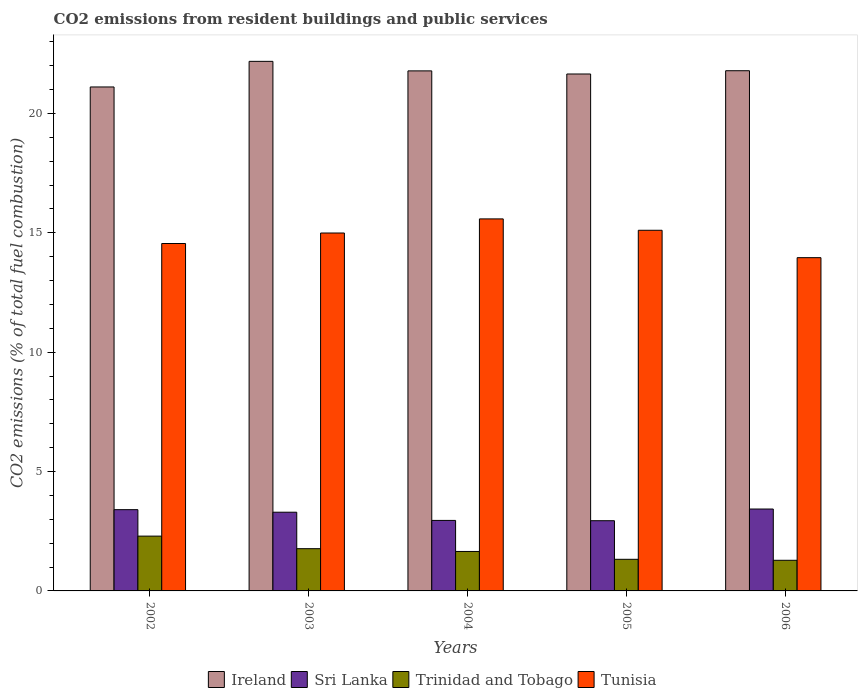How many groups of bars are there?
Ensure brevity in your answer.  5. Are the number of bars per tick equal to the number of legend labels?
Your response must be concise. Yes. Are the number of bars on each tick of the X-axis equal?
Keep it short and to the point. Yes. How many bars are there on the 1st tick from the right?
Your answer should be compact. 4. What is the total CO2 emitted in Trinidad and Tobago in 2002?
Your answer should be very brief. 2.3. Across all years, what is the maximum total CO2 emitted in Trinidad and Tobago?
Provide a short and direct response. 2.3. Across all years, what is the minimum total CO2 emitted in Sri Lanka?
Your answer should be compact. 2.94. In which year was the total CO2 emitted in Ireland minimum?
Your response must be concise. 2002. What is the total total CO2 emitted in Sri Lanka in the graph?
Provide a succinct answer. 16.03. What is the difference between the total CO2 emitted in Trinidad and Tobago in 2003 and that in 2005?
Your answer should be compact. 0.45. What is the difference between the total CO2 emitted in Trinidad and Tobago in 2005 and the total CO2 emitted in Ireland in 2004?
Give a very brief answer. -20.46. What is the average total CO2 emitted in Trinidad and Tobago per year?
Offer a very short reply. 1.67. In the year 2003, what is the difference between the total CO2 emitted in Ireland and total CO2 emitted in Trinidad and Tobago?
Ensure brevity in your answer.  20.41. In how many years, is the total CO2 emitted in Sri Lanka greater than 3?
Offer a terse response. 3. What is the ratio of the total CO2 emitted in Tunisia in 2003 to that in 2005?
Ensure brevity in your answer.  0.99. Is the total CO2 emitted in Trinidad and Tobago in 2002 less than that in 2006?
Ensure brevity in your answer.  No. What is the difference between the highest and the second highest total CO2 emitted in Sri Lanka?
Your answer should be compact. 0.03. What is the difference between the highest and the lowest total CO2 emitted in Sri Lanka?
Offer a very short reply. 0.49. In how many years, is the total CO2 emitted in Trinidad and Tobago greater than the average total CO2 emitted in Trinidad and Tobago taken over all years?
Make the answer very short. 2. Is it the case that in every year, the sum of the total CO2 emitted in Sri Lanka and total CO2 emitted in Ireland is greater than the sum of total CO2 emitted in Trinidad and Tobago and total CO2 emitted in Tunisia?
Your answer should be very brief. Yes. What does the 2nd bar from the left in 2002 represents?
Offer a terse response. Sri Lanka. What does the 3rd bar from the right in 2006 represents?
Your answer should be very brief. Sri Lanka. How many bars are there?
Your response must be concise. 20. How many legend labels are there?
Your answer should be very brief. 4. What is the title of the graph?
Ensure brevity in your answer.  CO2 emissions from resident buildings and public services. Does "Bolivia" appear as one of the legend labels in the graph?
Offer a terse response. No. What is the label or title of the X-axis?
Provide a short and direct response. Years. What is the label or title of the Y-axis?
Your answer should be very brief. CO2 emissions (% of total fuel combustion). What is the CO2 emissions (% of total fuel combustion) of Ireland in 2002?
Give a very brief answer. 21.11. What is the CO2 emissions (% of total fuel combustion) of Sri Lanka in 2002?
Ensure brevity in your answer.  3.4. What is the CO2 emissions (% of total fuel combustion) of Trinidad and Tobago in 2002?
Give a very brief answer. 2.3. What is the CO2 emissions (% of total fuel combustion) of Tunisia in 2002?
Keep it short and to the point. 14.55. What is the CO2 emissions (% of total fuel combustion) in Ireland in 2003?
Offer a terse response. 22.18. What is the CO2 emissions (% of total fuel combustion) of Sri Lanka in 2003?
Offer a very short reply. 3.3. What is the CO2 emissions (% of total fuel combustion) of Trinidad and Tobago in 2003?
Provide a short and direct response. 1.77. What is the CO2 emissions (% of total fuel combustion) in Tunisia in 2003?
Your response must be concise. 14.99. What is the CO2 emissions (% of total fuel combustion) of Ireland in 2004?
Make the answer very short. 21.78. What is the CO2 emissions (% of total fuel combustion) in Sri Lanka in 2004?
Your answer should be compact. 2.95. What is the CO2 emissions (% of total fuel combustion) of Trinidad and Tobago in 2004?
Keep it short and to the point. 1.65. What is the CO2 emissions (% of total fuel combustion) of Tunisia in 2004?
Your answer should be very brief. 15.58. What is the CO2 emissions (% of total fuel combustion) in Ireland in 2005?
Your response must be concise. 21.65. What is the CO2 emissions (% of total fuel combustion) of Sri Lanka in 2005?
Your answer should be very brief. 2.94. What is the CO2 emissions (% of total fuel combustion) of Trinidad and Tobago in 2005?
Ensure brevity in your answer.  1.32. What is the CO2 emissions (% of total fuel combustion) in Tunisia in 2005?
Provide a short and direct response. 15.11. What is the CO2 emissions (% of total fuel combustion) of Ireland in 2006?
Offer a terse response. 21.79. What is the CO2 emissions (% of total fuel combustion) of Sri Lanka in 2006?
Your answer should be compact. 3.43. What is the CO2 emissions (% of total fuel combustion) of Trinidad and Tobago in 2006?
Ensure brevity in your answer.  1.28. What is the CO2 emissions (% of total fuel combustion) of Tunisia in 2006?
Provide a short and direct response. 13.96. Across all years, what is the maximum CO2 emissions (% of total fuel combustion) in Ireland?
Provide a short and direct response. 22.18. Across all years, what is the maximum CO2 emissions (% of total fuel combustion) of Sri Lanka?
Your answer should be very brief. 3.43. Across all years, what is the maximum CO2 emissions (% of total fuel combustion) in Trinidad and Tobago?
Provide a succinct answer. 2.3. Across all years, what is the maximum CO2 emissions (% of total fuel combustion) of Tunisia?
Your answer should be very brief. 15.58. Across all years, what is the minimum CO2 emissions (% of total fuel combustion) in Ireland?
Offer a very short reply. 21.11. Across all years, what is the minimum CO2 emissions (% of total fuel combustion) in Sri Lanka?
Offer a very short reply. 2.94. Across all years, what is the minimum CO2 emissions (% of total fuel combustion) in Trinidad and Tobago?
Make the answer very short. 1.28. Across all years, what is the minimum CO2 emissions (% of total fuel combustion) of Tunisia?
Make the answer very short. 13.96. What is the total CO2 emissions (% of total fuel combustion) of Ireland in the graph?
Keep it short and to the point. 108.52. What is the total CO2 emissions (% of total fuel combustion) in Sri Lanka in the graph?
Keep it short and to the point. 16.03. What is the total CO2 emissions (% of total fuel combustion) of Trinidad and Tobago in the graph?
Your answer should be compact. 8.33. What is the total CO2 emissions (% of total fuel combustion) in Tunisia in the graph?
Make the answer very short. 74.19. What is the difference between the CO2 emissions (% of total fuel combustion) in Ireland in 2002 and that in 2003?
Provide a succinct answer. -1.07. What is the difference between the CO2 emissions (% of total fuel combustion) of Sri Lanka in 2002 and that in 2003?
Offer a terse response. 0.11. What is the difference between the CO2 emissions (% of total fuel combustion) in Trinidad and Tobago in 2002 and that in 2003?
Keep it short and to the point. 0.53. What is the difference between the CO2 emissions (% of total fuel combustion) of Tunisia in 2002 and that in 2003?
Ensure brevity in your answer.  -0.44. What is the difference between the CO2 emissions (% of total fuel combustion) of Ireland in 2002 and that in 2004?
Keep it short and to the point. -0.67. What is the difference between the CO2 emissions (% of total fuel combustion) in Sri Lanka in 2002 and that in 2004?
Give a very brief answer. 0.45. What is the difference between the CO2 emissions (% of total fuel combustion) in Trinidad and Tobago in 2002 and that in 2004?
Give a very brief answer. 0.64. What is the difference between the CO2 emissions (% of total fuel combustion) in Tunisia in 2002 and that in 2004?
Your response must be concise. -1.03. What is the difference between the CO2 emissions (% of total fuel combustion) in Ireland in 2002 and that in 2005?
Provide a short and direct response. -0.54. What is the difference between the CO2 emissions (% of total fuel combustion) of Sri Lanka in 2002 and that in 2005?
Offer a very short reply. 0.46. What is the difference between the CO2 emissions (% of total fuel combustion) of Trinidad and Tobago in 2002 and that in 2005?
Offer a very short reply. 0.97. What is the difference between the CO2 emissions (% of total fuel combustion) in Tunisia in 2002 and that in 2005?
Ensure brevity in your answer.  -0.55. What is the difference between the CO2 emissions (% of total fuel combustion) of Ireland in 2002 and that in 2006?
Provide a short and direct response. -0.68. What is the difference between the CO2 emissions (% of total fuel combustion) in Sri Lanka in 2002 and that in 2006?
Offer a terse response. -0.03. What is the difference between the CO2 emissions (% of total fuel combustion) in Trinidad and Tobago in 2002 and that in 2006?
Give a very brief answer. 1.01. What is the difference between the CO2 emissions (% of total fuel combustion) of Tunisia in 2002 and that in 2006?
Ensure brevity in your answer.  0.59. What is the difference between the CO2 emissions (% of total fuel combustion) in Ireland in 2003 and that in 2004?
Offer a very short reply. 0.4. What is the difference between the CO2 emissions (% of total fuel combustion) of Sri Lanka in 2003 and that in 2004?
Your answer should be compact. 0.34. What is the difference between the CO2 emissions (% of total fuel combustion) in Trinidad and Tobago in 2003 and that in 2004?
Your response must be concise. 0.12. What is the difference between the CO2 emissions (% of total fuel combustion) in Tunisia in 2003 and that in 2004?
Provide a short and direct response. -0.59. What is the difference between the CO2 emissions (% of total fuel combustion) in Ireland in 2003 and that in 2005?
Provide a succinct answer. 0.53. What is the difference between the CO2 emissions (% of total fuel combustion) in Sri Lanka in 2003 and that in 2005?
Your response must be concise. 0.36. What is the difference between the CO2 emissions (% of total fuel combustion) in Trinidad and Tobago in 2003 and that in 2005?
Offer a very short reply. 0.45. What is the difference between the CO2 emissions (% of total fuel combustion) of Tunisia in 2003 and that in 2005?
Offer a very short reply. -0.11. What is the difference between the CO2 emissions (% of total fuel combustion) in Ireland in 2003 and that in 2006?
Your response must be concise. 0.39. What is the difference between the CO2 emissions (% of total fuel combustion) in Sri Lanka in 2003 and that in 2006?
Your answer should be compact. -0.13. What is the difference between the CO2 emissions (% of total fuel combustion) in Trinidad and Tobago in 2003 and that in 2006?
Give a very brief answer. 0.49. What is the difference between the CO2 emissions (% of total fuel combustion) in Tunisia in 2003 and that in 2006?
Provide a succinct answer. 1.03. What is the difference between the CO2 emissions (% of total fuel combustion) in Ireland in 2004 and that in 2005?
Your answer should be compact. 0.13. What is the difference between the CO2 emissions (% of total fuel combustion) in Sri Lanka in 2004 and that in 2005?
Your response must be concise. 0.01. What is the difference between the CO2 emissions (% of total fuel combustion) in Trinidad and Tobago in 2004 and that in 2005?
Provide a succinct answer. 0.33. What is the difference between the CO2 emissions (% of total fuel combustion) in Tunisia in 2004 and that in 2005?
Make the answer very short. 0.48. What is the difference between the CO2 emissions (% of total fuel combustion) in Ireland in 2004 and that in 2006?
Provide a succinct answer. -0.01. What is the difference between the CO2 emissions (% of total fuel combustion) of Sri Lanka in 2004 and that in 2006?
Make the answer very short. -0.48. What is the difference between the CO2 emissions (% of total fuel combustion) of Trinidad and Tobago in 2004 and that in 2006?
Offer a terse response. 0.37. What is the difference between the CO2 emissions (% of total fuel combustion) in Tunisia in 2004 and that in 2006?
Offer a terse response. 1.62. What is the difference between the CO2 emissions (% of total fuel combustion) in Ireland in 2005 and that in 2006?
Your response must be concise. -0.14. What is the difference between the CO2 emissions (% of total fuel combustion) of Sri Lanka in 2005 and that in 2006?
Ensure brevity in your answer.  -0.49. What is the difference between the CO2 emissions (% of total fuel combustion) of Trinidad and Tobago in 2005 and that in 2006?
Your answer should be very brief. 0.04. What is the difference between the CO2 emissions (% of total fuel combustion) in Tunisia in 2005 and that in 2006?
Make the answer very short. 1.15. What is the difference between the CO2 emissions (% of total fuel combustion) in Ireland in 2002 and the CO2 emissions (% of total fuel combustion) in Sri Lanka in 2003?
Provide a short and direct response. 17.81. What is the difference between the CO2 emissions (% of total fuel combustion) in Ireland in 2002 and the CO2 emissions (% of total fuel combustion) in Trinidad and Tobago in 2003?
Your answer should be compact. 19.34. What is the difference between the CO2 emissions (% of total fuel combustion) in Ireland in 2002 and the CO2 emissions (% of total fuel combustion) in Tunisia in 2003?
Your answer should be very brief. 6.12. What is the difference between the CO2 emissions (% of total fuel combustion) of Sri Lanka in 2002 and the CO2 emissions (% of total fuel combustion) of Trinidad and Tobago in 2003?
Your answer should be compact. 1.63. What is the difference between the CO2 emissions (% of total fuel combustion) of Sri Lanka in 2002 and the CO2 emissions (% of total fuel combustion) of Tunisia in 2003?
Your answer should be compact. -11.59. What is the difference between the CO2 emissions (% of total fuel combustion) in Trinidad and Tobago in 2002 and the CO2 emissions (% of total fuel combustion) in Tunisia in 2003?
Provide a short and direct response. -12.7. What is the difference between the CO2 emissions (% of total fuel combustion) in Ireland in 2002 and the CO2 emissions (% of total fuel combustion) in Sri Lanka in 2004?
Your response must be concise. 18.16. What is the difference between the CO2 emissions (% of total fuel combustion) of Ireland in 2002 and the CO2 emissions (% of total fuel combustion) of Trinidad and Tobago in 2004?
Offer a terse response. 19.46. What is the difference between the CO2 emissions (% of total fuel combustion) of Ireland in 2002 and the CO2 emissions (% of total fuel combustion) of Tunisia in 2004?
Your response must be concise. 5.53. What is the difference between the CO2 emissions (% of total fuel combustion) of Sri Lanka in 2002 and the CO2 emissions (% of total fuel combustion) of Trinidad and Tobago in 2004?
Your response must be concise. 1.75. What is the difference between the CO2 emissions (% of total fuel combustion) of Sri Lanka in 2002 and the CO2 emissions (% of total fuel combustion) of Tunisia in 2004?
Make the answer very short. -12.18. What is the difference between the CO2 emissions (% of total fuel combustion) in Trinidad and Tobago in 2002 and the CO2 emissions (% of total fuel combustion) in Tunisia in 2004?
Provide a succinct answer. -13.29. What is the difference between the CO2 emissions (% of total fuel combustion) of Ireland in 2002 and the CO2 emissions (% of total fuel combustion) of Sri Lanka in 2005?
Ensure brevity in your answer.  18.17. What is the difference between the CO2 emissions (% of total fuel combustion) in Ireland in 2002 and the CO2 emissions (% of total fuel combustion) in Trinidad and Tobago in 2005?
Your answer should be compact. 19.79. What is the difference between the CO2 emissions (% of total fuel combustion) of Ireland in 2002 and the CO2 emissions (% of total fuel combustion) of Tunisia in 2005?
Provide a short and direct response. 6. What is the difference between the CO2 emissions (% of total fuel combustion) in Sri Lanka in 2002 and the CO2 emissions (% of total fuel combustion) in Trinidad and Tobago in 2005?
Offer a terse response. 2.08. What is the difference between the CO2 emissions (% of total fuel combustion) of Sri Lanka in 2002 and the CO2 emissions (% of total fuel combustion) of Tunisia in 2005?
Your answer should be compact. -11.7. What is the difference between the CO2 emissions (% of total fuel combustion) of Trinidad and Tobago in 2002 and the CO2 emissions (% of total fuel combustion) of Tunisia in 2005?
Provide a short and direct response. -12.81. What is the difference between the CO2 emissions (% of total fuel combustion) of Ireland in 2002 and the CO2 emissions (% of total fuel combustion) of Sri Lanka in 2006?
Your answer should be compact. 17.68. What is the difference between the CO2 emissions (% of total fuel combustion) in Ireland in 2002 and the CO2 emissions (% of total fuel combustion) in Trinidad and Tobago in 2006?
Give a very brief answer. 19.83. What is the difference between the CO2 emissions (% of total fuel combustion) in Ireland in 2002 and the CO2 emissions (% of total fuel combustion) in Tunisia in 2006?
Provide a short and direct response. 7.15. What is the difference between the CO2 emissions (% of total fuel combustion) of Sri Lanka in 2002 and the CO2 emissions (% of total fuel combustion) of Trinidad and Tobago in 2006?
Make the answer very short. 2.12. What is the difference between the CO2 emissions (% of total fuel combustion) of Sri Lanka in 2002 and the CO2 emissions (% of total fuel combustion) of Tunisia in 2006?
Offer a very short reply. -10.56. What is the difference between the CO2 emissions (% of total fuel combustion) of Trinidad and Tobago in 2002 and the CO2 emissions (% of total fuel combustion) of Tunisia in 2006?
Offer a very short reply. -11.66. What is the difference between the CO2 emissions (% of total fuel combustion) in Ireland in 2003 and the CO2 emissions (% of total fuel combustion) in Sri Lanka in 2004?
Offer a very short reply. 19.23. What is the difference between the CO2 emissions (% of total fuel combustion) in Ireland in 2003 and the CO2 emissions (% of total fuel combustion) in Trinidad and Tobago in 2004?
Ensure brevity in your answer.  20.53. What is the difference between the CO2 emissions (% of total fuel combustion) in Ireland in 2003 and the CO2 emissions (% of total fuel combustion) in Tunisia in 2004?
Make the answer very short. 6.6. What is the difference between the CO2 emissions (% of total fuel combustion) of Sri Lanka in 2003 and the CO2 emissions (% of total fuel combustion) of Trinidad and Tobago in 2004?
Give a very brief answer. 1.64. What is the difference between the CO2 emissions (% of total fuel combustion) of Sri Lanka in 2003 and the CO2 emissions (% of total fuel combustion) of Tunisia in 2004?
Your response must be concise. -12.29. What is the difference between the CO2 emissions (% of total fuel combustion) in Trinidad and Tobago in 2003 and the CO2 emissions (% of total fuel combustion) in Tunisia in 2004?
Give a very brief answer. -13.81. What is the difference between the CO2 emissions (% of total fuel combustion) in Ireland in 2003 and the CO2 emissions (% of total fuel combustion) in Sri Lanka in 2005?
Your response must be concise. 19.24. What is the difference between the CO2 emissions (% of total fuel combustion) of Ireland in 2003 and the CO2 emissions (% of total fuel combustion) of Trinidad and Tobago in 2005?
Your answer should be compact. 20.86. What is the difference between the CO2 emissions (% of total fuel combustion) of Ireland in 2003 and the CO2 emissions (% of total fuel combustion) of Tunisia in 2005?
Your answer should be very brief. 7.08. What is the difference between the CO2 emissions (% of total fuel combustion) in Sri Lanka in 2003 and the CO2 emissions (% of total fuel combustion) in Trinidad and Tobago in 2005?
Give a very brief answer. 1.97. What is the difference between the CO2 emissions (% of total fuel combustion) in Sri Lanka in 2003 and the CO2 emissions (% of total fuel combustion) in Tunisia in 2005?
Your answer should be compact. -11.81. What is the difference between the CO2 emissions (% of total fuel combustion) in Trinidad and Tobago in 2003 and the CO2 emissions (% of total fuel combustion) in Tunisia in 2005?
Your answer should be very brief. -13.34. What is the difference between the CO2 emissions (% of total fuel combustion) of Ireland in 2003 and the CO2 emissions (% of total fuel combustion) of Sri Lanka in 2006?
Your answer should be very brief. 18.75. What is the difference between the CO2 emissions (% of total fuel combustion) in Ireland in 2003 and the CO2 emissions (% of total fuel combustion) in Trinidad and Tobago in 2006?
Make the answer very short. 20.9. What is the difference between the CO2 emissions (% of total fuel combustion) of Ireland in 2003 and the CO2 emissions (% of total fuel combustion) of Tunisia in 2006?
Offer a terse response. 8.22. What is the difference between the CO2 emissions (% of total fuel combustion) of Sri Lanka in 2003 and the CO2 emissions (% of total fuel combustion) of Trinidad and Tobago in 2006?
Your response must be concise. 2.01. What is the difference between the CO2 emissions (% of total fuel combustion) of Sri Lanka in 2003 and the CO2 emissions (% of total fuel combustion) of Tunisia in 2006?
Provide a succinct answer. -10.66. What is the difference between the CO2 emissions (% of total fuel combustion) of Trinidad and Tobago in 2003 and the CO2 emissions (% of total fuel combustion) of Tunisia in 2006?
Your response must be concise. -12.19. What is the difference between the CO2 emissions (% of total fuel combustion) in Ireland in 2004 and the CO2 emissions (% of total fuel combustion) in Sri Lanka in 2005?
Your answer should be compact. 18.84. What is the difference between the CO2 emissions (% of total fuel combustion) of Ireland in 2004 and the CO2 emissions (% of total fuel combustion) of Trinidad and Tobago in 2005?
Provide a succinct answer. 20.46. What is the difference between the CO2 emissions (% of total fuel combustion) in Ireland in 2004 and the CO2 emissions (% of total fuel combustion) in Tunisia in 2005?
Your answer should be very brief. 6.68. What is the difference between the CO2 emissions (% of total fuel combustion) of Sri Lanka in 2004 and the CO2 emissions (% of total fuel combustion) of Trinidad and Tobago in 2005?
Provide a succinct answer. 1.63. What is the difference between the CO2 emissions (% of total fuel combustion) of Sri Lanka in 2004 and the CO2 emissions (% of total fuel combustion) of Tunisia in 2005?
Make the answer very short. -12.15. What is the difference between the CO2 emissions (% of total fuel combustion) in Trinidad and Tobago in 2004 and the CO2 emissions (% of total fuel combustion) in Tunisia in 2005?
Your response must be concise. -13.45. What is the difference between the CO2 emissions (% of total fuel combustion) of Ireland in 2004 and the CO2 emissions (% of total fuel combustion) of Sri Lanka in 2006?
Your answer should be compact. 18.35. What is the difference between the CO2 emissions (% of total fuel combustion) of Ireland in 2004 and the CO2 emissions (% of total fuel combustion) of Trinidad and Tobago in 2006?
Make the answer very short. 20.5. What is the difference between the CO2 emissions (% of total fuel combustion) in Ireland in 2004 and the CO2 emissions (% of total fuel combustion) in Tunisia in 2006?
Ensure brevity in your answer.  7.82. What is the difference between the CO2 emissions (% of total fuel combustion) in Sri Lanka in 2004 and the CO2 emissions (% of total fuel combustion) in Trinidad and Tobago in 2006?
Your answer should be compact. 1.67. What is the difference between the CO2 emissions (% of total fuel combustion) in Sri Lanka in 2004 and the CO2 emissions (% of total fuel combustion) in Tunisia in 2006?
Your answer should be compact. -11.01. What is the difference between the CO2 emissions (% of total fuel combustion) in Trinidad and Tobago in 2004 and the CO2 emissions (% of total fuel combustion) in Tunisia in 2006?
Your answer should be compact. -12.31. What is the difference between the CO2 emissions (% of total fuel combustion) in Ireland in 2005 and the CO2 emissions (% of total fuel combustion) in Sri Lanka in 2006?
Provide a short and direct response. 18.22. What is the difference between the CO2 emissions (% of total fuel combustion) in Ireland in 2005 and the CO2 emissions (% of total fuel combustion) in Trinidad and Tobago in 2006?
Provide a succinct answer. 20.37. What is the difference between the CO2 emissions (% of total fuel combustion) of Ireland in 2005 and the CO2 emissions (% of total fuel combustion) of Tunisia in 2006?
Your response must be concise. 7.69. What is the difference between the CO2 emissions (% of total fuel combustion) of Sri Lanka in 2005 and the CO2 emissions (% of total fuel combustion) of Trinidad and Tobago in 2006?
Your response must be concise. 1.66. What is the difference between the CO2 emissions (% of total fuel combustion) of Sri Lanka in 2005 and the CO2 emissions (% of total fuel combustion) of Tunisia in 2006?
Offer a very short reply. -11.02. What is the difference between the CO2 emissions (% of total fuel combustion) in Trinidad and Tobago in 2005 and the CO2 emissions (% of total fuel combustion) in Tunisia in 2006?
Provide a succinct answer. -12.63. What is the average CO2 emissions (% of total fuel combustion) in Ireland per year?
Your answer should be very brief. 21.7. What is the average CO2 emissions (% of total fuel combustion) of Sri Lanka per year?
Keep it short and to the point. 3.21. What is the average CO2 emissions (% of total fuel combustion) of Trinidad and Tobago per year?
Your response must be concise. 1.67. What is the average CO2 emissions (% of total fuel combustion) of Tunisia per year?
Give a very brief answer. 14.84. In the year 2002, what is the difference between the CO2 emissions (% of total fuel combustion) in Ireland and CO2 emissions (% of total fuel combustion) in Sri Lanka?
Provide a short and direct response. 17.71. In the year 2002, what is the difference between the CO2 emissions (% of total fuel combustion) of Ireland and CO2 emissions (% of total fuel combustion) of Trinidad and Tobago?
Provide a succinct answer. 18.81. In the year 2002, what is the difference between the CO2 emissions (% of total fuel combustion) in Ireland and CO2 emissions (% of total fuel combustion) in Tunisia?
Offer a very short reply. 6.56. In the year 2002, what is the difference between the CO2 emissions (% of total fuel combustion) in Sri Lanka and CO2 emissions (% of total fuel combustion) in Trinidad and Tobago?
Your response must be concise. 1.11. In the year 2002, what is the difference between the CO2 emissions (% of total fuel combustion) of Sri Lanka and CO2 emissions (% of total fuel combustion) of Tunisia?
Offer a very short reply. -11.15. In the year 2002, what is the difference between the CO2 emissions (% of total fuel combustion) of Trinidad and Tobago and CO2 emissions (% of total fuel combustion) of Tunisia?
Keep it short and to the point. -12.26. In the year 2003, what is the difference between the CO2 emissions (% of total fuel combustion) of Ireland and CO2 emissions (% of total fuel combustion) of Sri Lanka?
Provide a succinct answer. 18.89. In the year 2003, what is the difference between the CO2 emissions (% of total fuel combustion) in Ireland and CO2 emissions (% of total fuel combustion) in Trinidad and Tobago?
Offer a terse response. 20.41. In the year 2003, what is the difference between the CO2 emissions (% of total fuel combustion) of Ireland and CO2 emissions (% of total fuel combustion) of Tunisia?
Give a very brief answer. 7.19. In the year 2003, what is the difference between the CO2 emissions (% of total fuel combustion) of Sri Lanka and CO2 emissions (% of total fuel combustion) of Trinidad and Tobago?
Your response must be concise. 1.53. In the year 2003, what is the difference between the CO2 emissions (% of total fuel combustion) of Sri Lanka and CO2 emissions (% of total fuel combustion) of Tunisia?
Your answer should be compact. -11.7. In the year 2003, what is the difference between the CO2 emissions (% of total fuel combustion) of Trinidad and Tobago and CO2 emissions (% of total fuel combustion) of Tunisia?
Offer a very short reply. -13.22. In the year 2004, what is the difference between the CO2 emissions (% of total fuel combustion) of Ireland and CO2 emissions (% of total fuel combustion) of Sri Lanka?
Ensure brevity in your answer.  18.83. In the year 2004, what is the difference between the CO2 emissions (% of total fuel combustion) in Ireland and CO2 emissions (% of total fuel combustion) in Trinidad and Tobago?
Offer a terse response. 20.13. In the year 2004, what is the difference between the CO2 emissions (% of total fuel combustion) in Ireland and CO2 emissions (% of total fuel combustion) in Tunisia?
Provide a short and direct response. 6.2. In the year 2004, what is the difference between the CO2 emissions (% of total fuel combustion) of Sri Lanka and CO2 emissions (% of total fuel combustion) of Trinidad and Tobago?
Provide a succinct answer. 1.3. In the year 2004, what is the difference between the CO2 emissions (% of total fuel combustion) of Sri Lanka and CO2 emissions (% of total fuel combustion) of Tunisia?
Make the answer very short. -12.63. In the year 2004, what is the difference between the CO2 emissions (% of total fuel combustion) in Trinidad and Tobago and CO2 emissions (% of total fuel combustion) in Tunisia?
Your response must be concise. -13.93. In the year 2005, what is the difference between the CO2 emissions (% of total fuel combustion) of Ireland and CO2 emissions (% of total fuel combustion) of Sri Lanka?
Ensure brevity in your answer.  18.71. In the year 2005, what is the difference between the CO2 emissions (% of total fuel combustion) of Ireland and CO2 emissions (% of total fuel combustion) of Trinidad and Tobago?
Provide a succinct answer. 20.33. In the year 2005, what is the difference between the CO2 emissions (% of total fuel combustion) of Ireland and CO2 emissions (% of total fuel combustion) of Tunisia?
Provide a short and direct response. 6.55. In the year 2005, what is the difference between the CO2 emissions (% of total fuel combustion) of Sri Lanka and CO2 emissions (% of total fuel combustion) of Trinidad and Tobago?
Your answer should be compact. 1.62. In the year 2005, what is the difference between the CO2 emissions (% of total fuel combustion) of Sri Lanka and CO2 emissions (% of total fuel combustion) of Tunisia?
Make the answer very short. -12.17. In the year 2005, what is the difference between the CO2 emissions (% of total fuel combustion) of Trinidad and Tobago and CO2 emissions (% of total fuel combustion) of Tunisia?
Offer a very short reply. -13.78. In the year 2006, what is the difference between the CO2 emissions (% of total fuel combustion) in Ireland and CO2 emissions (% of total fuel combustion) in Sri Lanka?
Provide a succinct answer. 18.36. In the year 2006, what is the difference between the CO2 emissions (% of total fuel combustion) in Ireland and CO2 emissions (% of total fuel combustion) in Trinidad and Tobago?
Keep it short and to the point. 20.51. In the year 2006, what is the difference between the CO2 emissions (% of total fuel combustion) of Ireland and CO2 emissions (% of total fuel combustion) of Tunisia?
Your answer should be compact. 7.83. In the year 2006, what is the difference between the CO2 emissions (% of total fuel combustion) of Sri Lanka and CO2 emissions (% of total fuel combustion) of Trinidad and Tobago?
Ensure brevity in your answer.  2.15. In the year 2006, what is the difference between the CO2 emissions (% of total fuel combustion) of Sri Lanka and CO2 emissions (% of total fuel combustion) of Tunisia?
Your answer should be very brief. -10.53. In the year 2006, what is the difference between the CO2 emissions (% of total fuel combustion) in Trinidad and Tobago and CO2 emissions (% of total fuel combustion) in Tunisia?
Your response must be concise. -12.68. What is the ratio of the CO2 emissions (% of total fuel combustion) in Ireland in 2002 to that in 2003?
Your answer should be very brief. 0.95. What is the ratio of the CO2 emissions (% of total fuel combustion) of Sri Lanka in 2002 to that in 2003?
Provide a succinct answer. 1.03. What is the ratio of the CO2 emissions (% of total fuel combustion) of Trinidad and Tobago in 2002 to that in 2003?
Offer a very short reply. 1.3. What is the ratio of the CO2 emissions (% of total fuel combustion) of Tunisia in 2002 to that in 2003?
Make the answer very short. 0.97. What is the ratio of the CO2 emissions (% of total fuel combustion) of Ireland in 2002 to that in 2004?
Keep it short and to the point. 0.97. What is the ratio of the CO2 emissions (% of total fuel combustion) of Sri Lanka in 2002 to that in 2004?
Your answer should be very brief. 1.15. What is the ratio of the CO2 emissions (% of total fuel combustion) of Trinidad and Tobago in 2002 to that in 2004?
Your answer should be compact. 1.39. What is the ratio of the CO2 emissions (% of total fuel combustion) in Tunisia in 2002 to that in 2004?
Provide a short and direct response. 0.93. What is the ratio of the CO2 emissions (% of total fuel combustion) of Ireland in 2002 to that in 2005?
Keep it short and to the point. 0.97. What is the ratio of the CO2 emissions (% of total fuel combustion) of Sri Lanka in 2002 to that in 2005?
Your answer should be very brief. 1.16. What is the ratio of the CO2 emissions (% of total fuel combustion) of Trinidad and Tobago in 2002 to that in 2005?
Provide a short and direct response. 1.73. What is the ratio of the CO2 emissions (% of total fuel combustion) in Tunisia in 2002 to that in 2005?
Provide a succinct answer. 0.96. What is the ratio of the CO2 emissions (% of total fuel combustion) in Ireland in 2002 to that in 2006?
Ensure brevity in your answer.  0.97. What is the ratio of the CO2 emissions (% of total fuel combustion) in Trinidad and Tobago in 2002 to that in 2006?
Offer a terse response. 1.79. What is the ratio of the CO2 emissions (% of total fuel combustion) of Tunisia in 2002 to that in 2006?
Ensure brevity in your answer.  1.04. What is the ratio of the CO2 emissions (% of total fuel combustion) of Ireland in 2003 to that in 2004?
Your answer should be compact. 1.02. What is the ratio of the CO2 emissions (% of total fuel combustion) in Sri Lanka in 2003 to that in 2004?
Ensure brevity in your answer.  1.12. What is the ratio of the CO2 emissions (% of total fuel combustion) in Trinidad and Tobago in 2003 to that in 2004?
Give a very brief answer. 1.07. What is the ratio of the CO2 emissions (% of total fuel combustion) of Tunisia in 2003 to that in 2004?
Ensure brevity in your answer.  0.96. What is the ratio of the CO2 emissions (% of total fuel combustion) in Ireland in 2003 to that in 2005?
Give a very brief answer. 1.02. What is the ratio of the CO2 emissions (% of total fuel combustion) of Sri Lanka in 2003 to that in 2005?
Provide a succinct answer. 1.12. What is the ratio of the CO2 emissions (% of total fuel combustion) in Trinidad and Tobago in 2003 to that in 2005?
Offer a terse response. 1.34. What is the ratio of the CO2 emissions (% of total fuel combustion) of Tunisia in 2003 to that in 2005?
Provide a succinct answer. 0.99. What is the ratio of the CO2 emissions (% of total fuel combustion) in Sri Lanka in 2003 to that in 2006?
Make the answer very short. 0.96. What is the ratio of the CO2 emissions (% of total fuel combustion) of Trinidad and Tobago in 2003 to that in 2006?
Offer a terse response. 1.38. What is the ratio of the CO2 emissions (% of total fuel combustion) of Tunisia in 2003 to that in 2006?
Provide a short and direct response. 1.07. What is the ratio of the CO2 emissions (% of total fuel combustion) in Ireland in 2004 to that in 2005?
Ensure brevity in your answer.  1.01. What is the ratio of the CO2 emissions (% of total fuel combustion) of Trinidad and Tobago in 2004 to that in 2005?
Offer a very short reply. 1.25. What is the ratio of the CO2 emissions (% of total fuel combustion) of Tunisia in 2004 to that in 2005?
Keep it short and to the point. 1.03. What is the ratio of the CO2 emissions (% of total fuel combustion) in Sri Lanka in 2004 to that in 2006?
Offer a terse response. 0.86. What is the ratio of the CO2 emissions (% of total fuel combustion) of Trinidad and Tobago in 2004 to that in 2006?
Give a very brief answer. 1.29. What is the ratio of the CO2 emissions (% of total fuel combustion) in Tunisia in 2004 to that in 2006?
Your response must be concise. 1.12. What is the ratio of the CO2 emissions (% of total fuel combustion) in Ireland in 2005 to that in 2006?
Provide a succinct answer. 0.99. What is the ratio of the CO2 emissions (% of total fuel combustion) in Sri Lanka in 2005 to that in 2006?
Give a very brief answer. 0.86. What is the ratio of the CO2 emissions (% of total fuel combustion) in Trinidad and Tobago in 2005 to that in 2006?
Provide a short and direct response. 1.03. What is the ratio of the CO2 emissions (% of total fuel combustion) in Tunisia in 2005 to that in 2006?
Your response must be concise. 1.08. What is the difference between the highest and the second highest CO2 emissions (% of total fuel combustion) in Ireland?
Give a very brief answer. 0.39. What is the difference between the highest and the second highest CO2 emissions (% of total fuel combustion) in Sri Lanka?
Offer a terse response. 0.03. What is the difference between the highest and the second highest CO2 emissions (% of total fuel combustion) of Trinidad and Tobago?
Give a very brief answer. 0.53. What is the difference between the highest and the second highest CO2 emissions (% of total fuel combustion) in Tunisia?
Offer a very short reply. 0.48. What is the difference between the highest and the lowest CO2 emissions (% of total fuel combustion) in Ireland?
Provide a short and direct response. 1.07. What is the difference between the highest and the lowest CO2 emissions (% of total fuel combustion) of Sri Lanka?
Your answer should be compact. 0.49. What is the difference between the highest and the lowest CO2 emissions (% of total fuel combustion) of Tunisia?
Give a very brief answer. 1.62. 